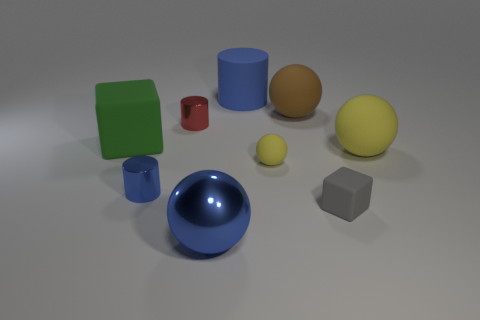There is a cube on the right side of the thing in front of the gray matte cube; what color is it?
Keep it short and to the point. Gray. Do the gray rubber cube and the blue metal cylinder have the same size?
Make the answer very short. Yes. Does the large sphere on the right side of the gray block have the same material as the big blue object that is behind the large metal sphere?
Provide a succinct answer. Yes. What shape is the small metal thing in front of the tiny shiny cylinder that is behind the matte thing left of the big blue cylinder?
Ensure brevity in your answer.  Cylinder. Is the number of blue spheres greater than the number of small metal things?
Make the answer very short. No. Are there any big cubes?
Your answer should be compact. Yes. What number of objects are blue metal objects in front of the small matte cube or big blue objects that are in front of the small blue metal thing?
Make the answer very short. 1. Do the big metal ball and the rubber cylinder have the same color?
Provide a short and direct response. Yes. Is the number of blue balls less than the number of red matte balls?
Your answer should be very brief. No. There is a matte cylinder; are there any tiny cylinders to the right of it?
Your answer should be compact. No. 